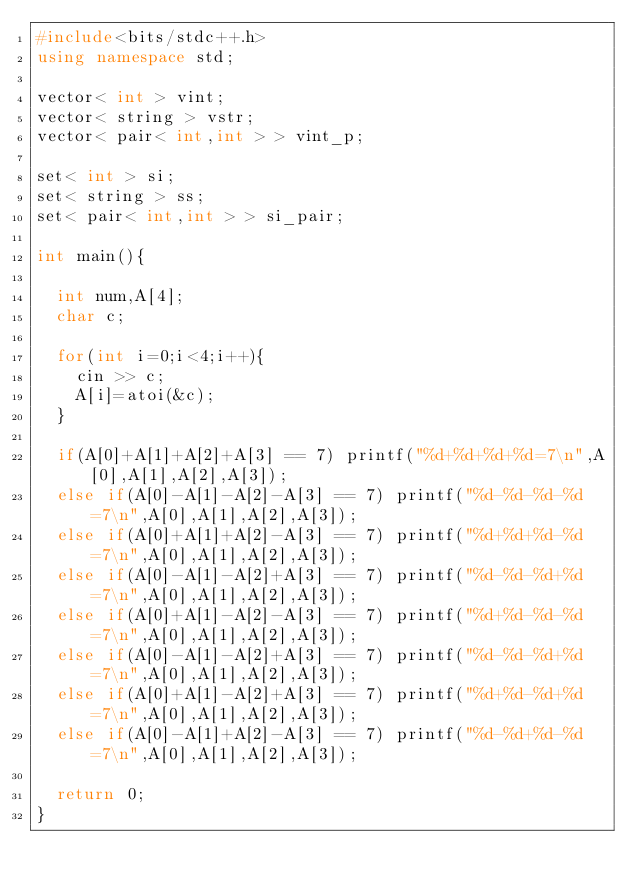Convert code to text. <code><loc_0><loc_0><loc_500><loc_500><_C++_>#include<bits/stdc++.h>
using namespace std;

vector< int > vint;
vector< string > vstr;
vector< pair< int,int > > vint_p;

set< int > si;
set< string > ss;
set< pair< int,int > > si_pair;

int main(){
  
  int num,A[4];
  char c;

  for(int i=0;i<4;i++){
    cin >> c;
    A[i]=atoi(&c);
  }

  if(A[0]+A[1]+A[2]+A[3] == 7) printf("%d+%d+%d+%d=7\n",A[0],A[1],A[2],A[3]);
  else if(A[0]-A[1]-A[2]-A[3] == 7) printf("%d-%d-%d-%d=7\n",A[0],A[1],A[2],A[3]);
  else if(A[0]+A[1]+A[2]-A[3] == 7) printf("%d+%d+%d-%d=7\n",A[0],A[1],A[2],A[3]);
  else if(A[0]-A[1]-A[2]+A[3] == 7) printf("%d-%d-%d+%d=7\n",A[0],A[1],A[2],A[3]);
  else if(A[0]+A[1]-A[2]-A[3] == 7) printf("%d+%d-%d-%d=7\n",A[0],A[1],A[2],A[3]);
  else if(A[0]-A[1]-A[2]+A[3] == 7) printf("%d-%d-%d+%d=7\n",A[0],A[1],A[2],A[3]);
  else if(A[0]+A[1]-A[2]+A[3] == 7) printf("%d+%d-%d+%d=7\n",A[0],A[1],A[2],A[3]);
  else if(A[0]-A[1]+A[2]-A[3] == 7) printf("%d-%d+%d-%d=7\n",A[0],A[1],A[2],A[3]);

  return 0;
}
</code> 